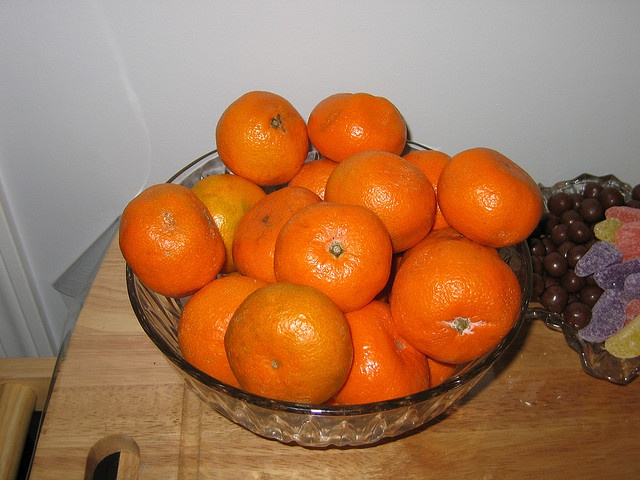Describe the objects in this image and their specific colors. I can see dining table in darkgray, red, brown, gray, and black tones, bowl in darkgray, red, brown, and maroon tones, orange in darkgray, red, brown, and orange tones, orange in darkgray, red, brown, and maroon tones, and orange in darkgray, red, orange, and maroon tones in this image. 